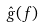Convert formula to latex. <formula><loc_0><loc_0><loc_500><loc_500>\hat { g } ( f )</formula> 